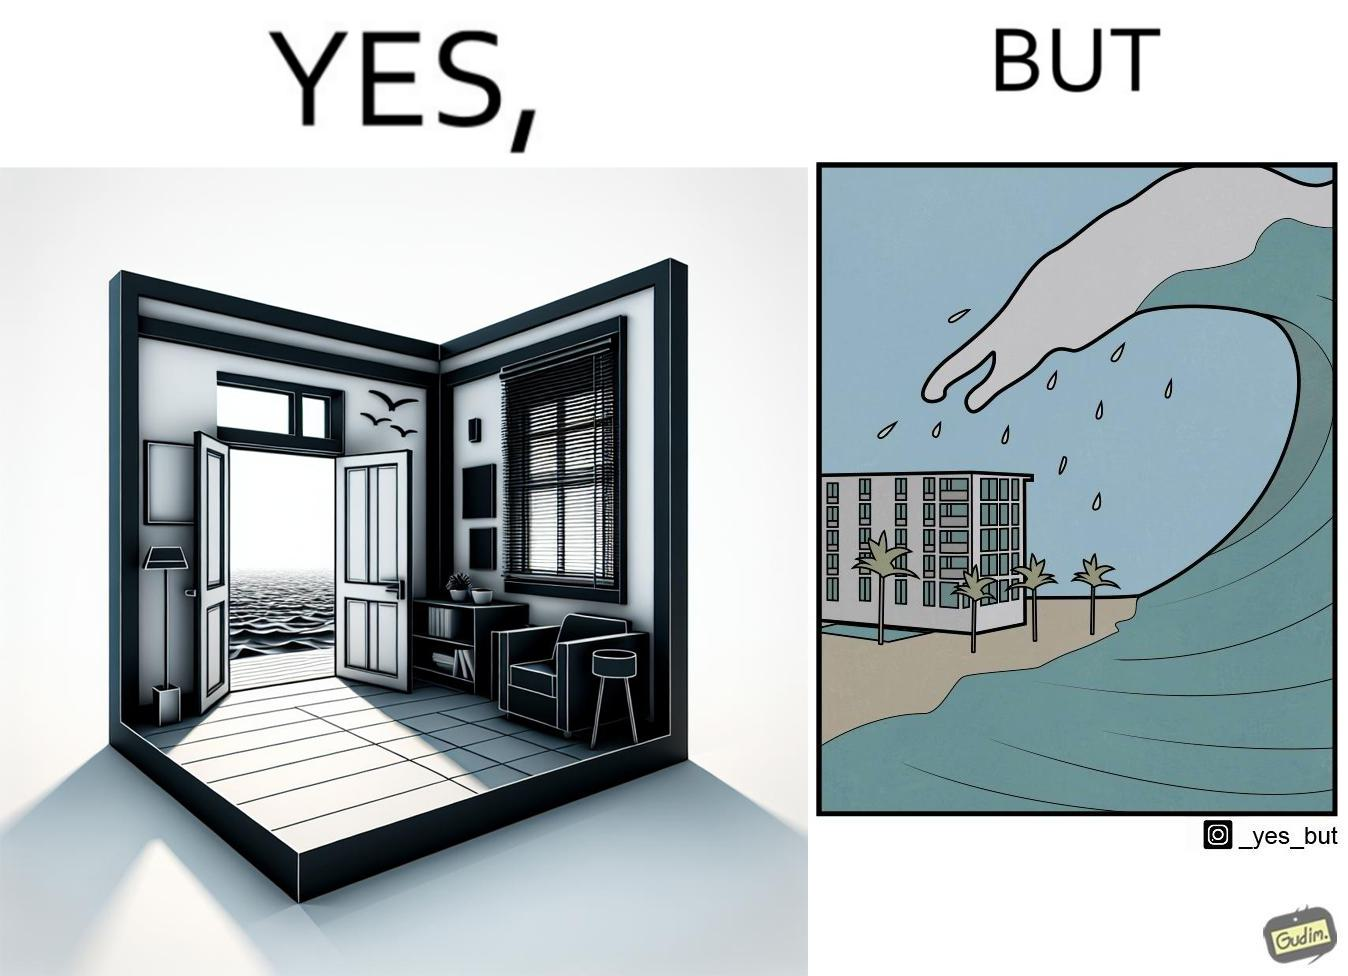Does this image contain satire or humor? Yes, this image is satirical. 